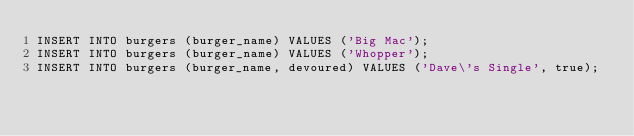Convert code to text. <code><loc_0><loc_0><loc_500><loc_500><_SQL_>INSERT INTO burgers (burger_name) VALUES ('Big Mac');
INSERT INTO burgers (burger_name) VALUES ('Whopper');
INSERT INTO burgers (burger_name, devoured) VALUES ('Dave\'s Single', true);
</code> 